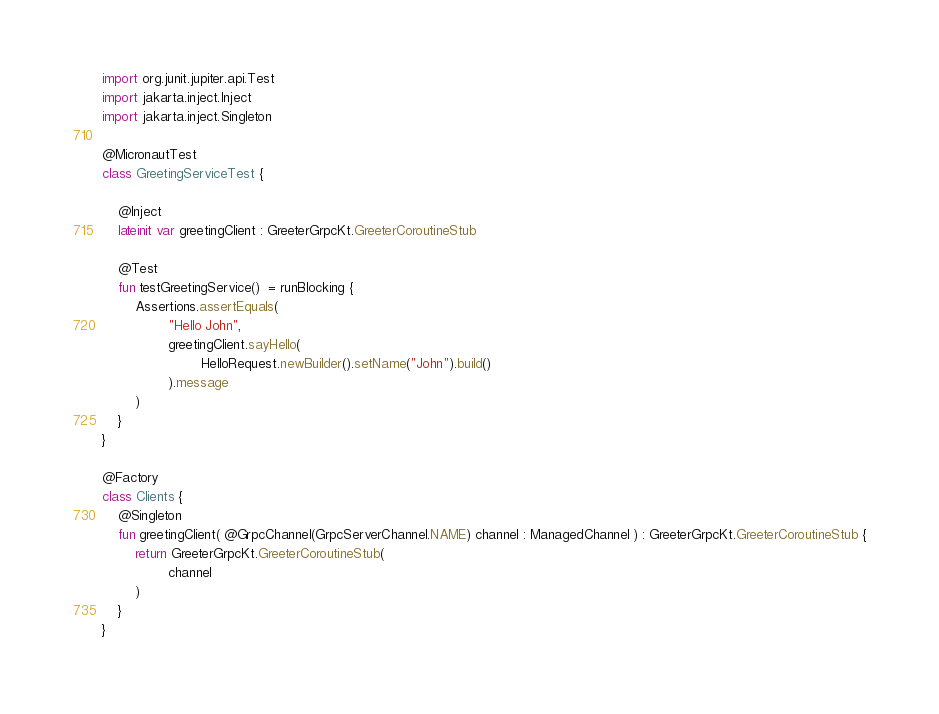<code> <loc_0><loc_0><loc_500><loc_500><_Kotlin_>import org.junit.jupiter.api.Test
import jakarta.inject.Inject
import jakarta.inject.Singleton

@MicronautTest
class GreetingServiceTest {

    @Inject
    lateinit var greetingClient : GreeterGrpcKt.GreeterCoroutineStub

    @Test
    fun testGreetingService()  = runBlocking {
        Assertions.assertEquals(
                "Hello John",
                greetingClient.sayHello(
                        HelloRequest.newBuilder().setName("John").build()
                ).message
        )
    }
}

@Factory
class Clients {
    @Singleton
    fun greetingClient( @GrpcChannel(GrpcServerChannel.NAME) channel : ManagedChannel ) : GreeterGrpcKt.GreeterCoroutineStub {
        return GreeterGrpcKt.GreeterCoroutineStub(
                channel
        )
    }
}</code> 